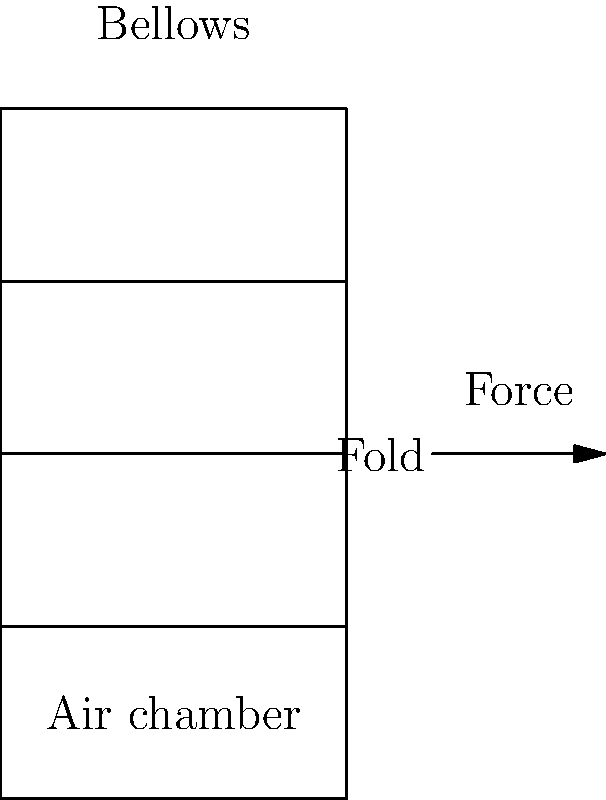In a concertina's bellows, what is the primary function of the folds in relation to the instrument's air flow and sound production? To understand the function of the folds in a concertina's bellows, let's break it down step-by-step:

1. Structure: The bellows of a concertina consist of multiple folds of material (usually leather or a synthetic alternative) arranged in an accordion-like pattern.

2. Expansion and contraction: When the concertina is played, the bellows are expanded and contracted by the player's hands.

3. Air chamber: The space inside the bellows forms an air chamber.

4. Air flow: As the bellows expand, they draw air in through the instrument's valves. When compressed, they force air out through the reeds.

5. Folds' role:
   a) Flexibility: The folds allow the bellows to expand and contract smoothly.
   b) Surface area: They increase the surface area of the air chamber without increasing its volume significantly when compressed.
   c) Controlled compression: The folds enable a controlled and even compression of air.

6. Sound production: The controlled air flow created by the expanding and contracting bellows passes over the reeds, causing them to vibrate and produce sound.

7. Efficiency: The folds' design maximizes the amount of air that can be moved with minimal effort from the player.

In essence, the folds in the bellows are crucial for creating a flexible, efficient air pump that can produce the precise air pressure needed to play the concertina effectively.
Answer: To allow flexible expansion and contraction, increasing air chamber surface area for efficient, controlled airflow over the reeds. 